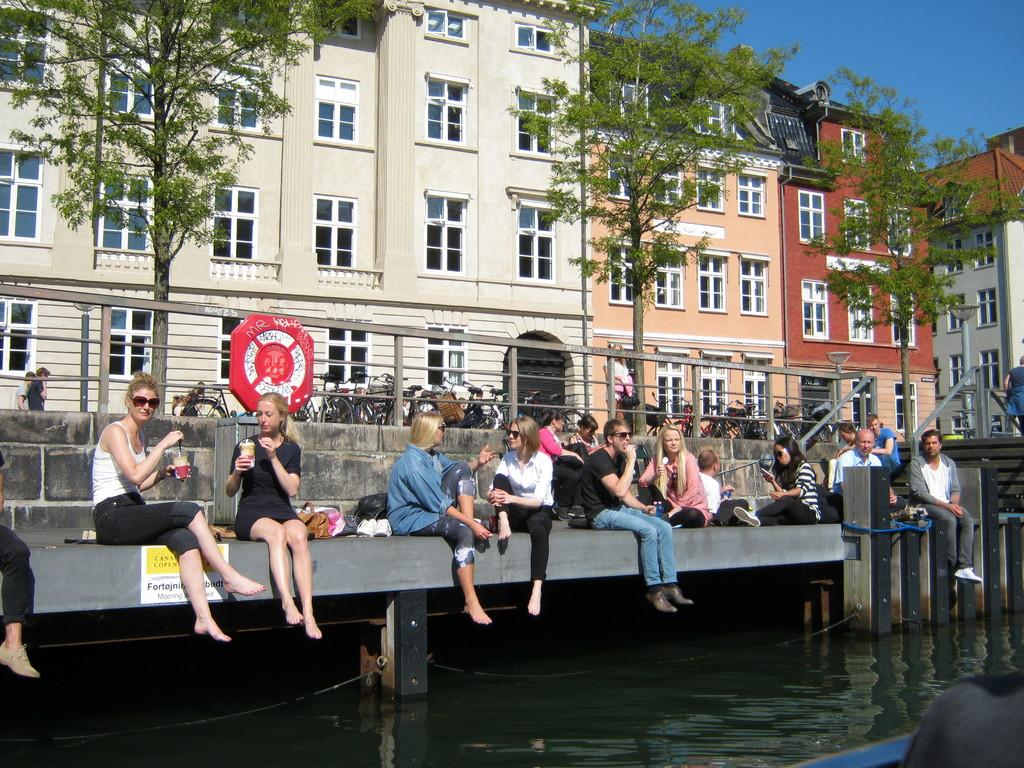What type of structure is in the image? There is a bridge-like structure in the image. What is happening on the bridge-like structure? People are seated on the bridge-like structure. What can be seen around the bridge-like structure? There is a fencing, buildings, and trees visible in the image. What is on the other side of the fencing? Vehicles are visible on the other side of the fencing. How many girls are copying their minds in the image? There are no girls or any mention of copying minds in the image. 